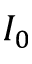Convert formula to latex. <formula><loc_0><loc_0><loc_500><loc_500>I _ { 0 }</formula> 